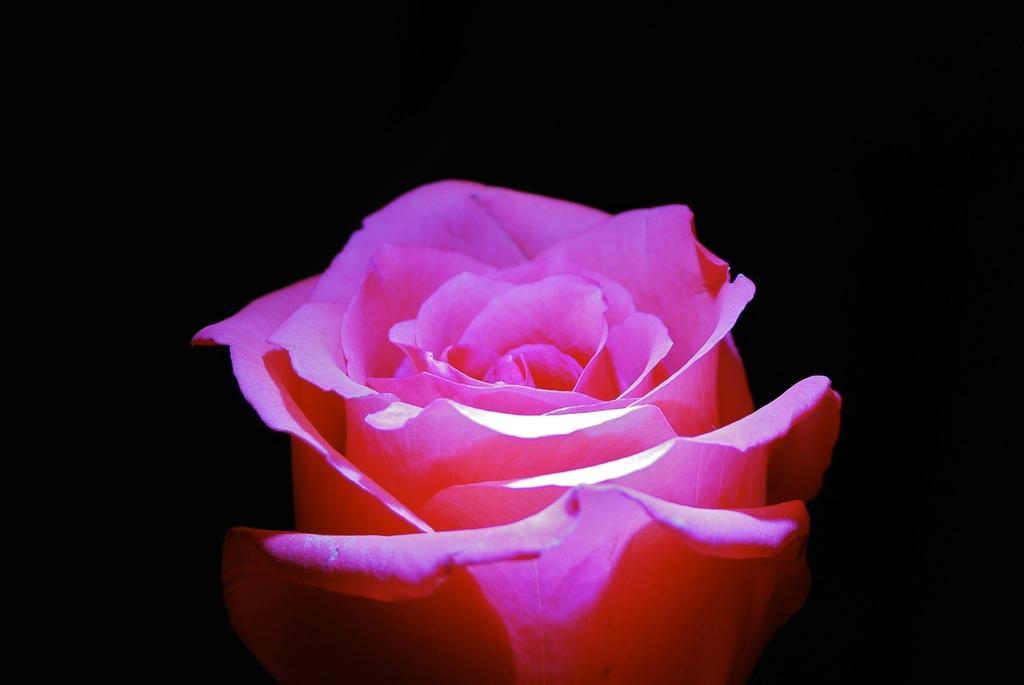How would you summarize this image in a sentence or two? We can see pink flowers. In the background it is dark. 